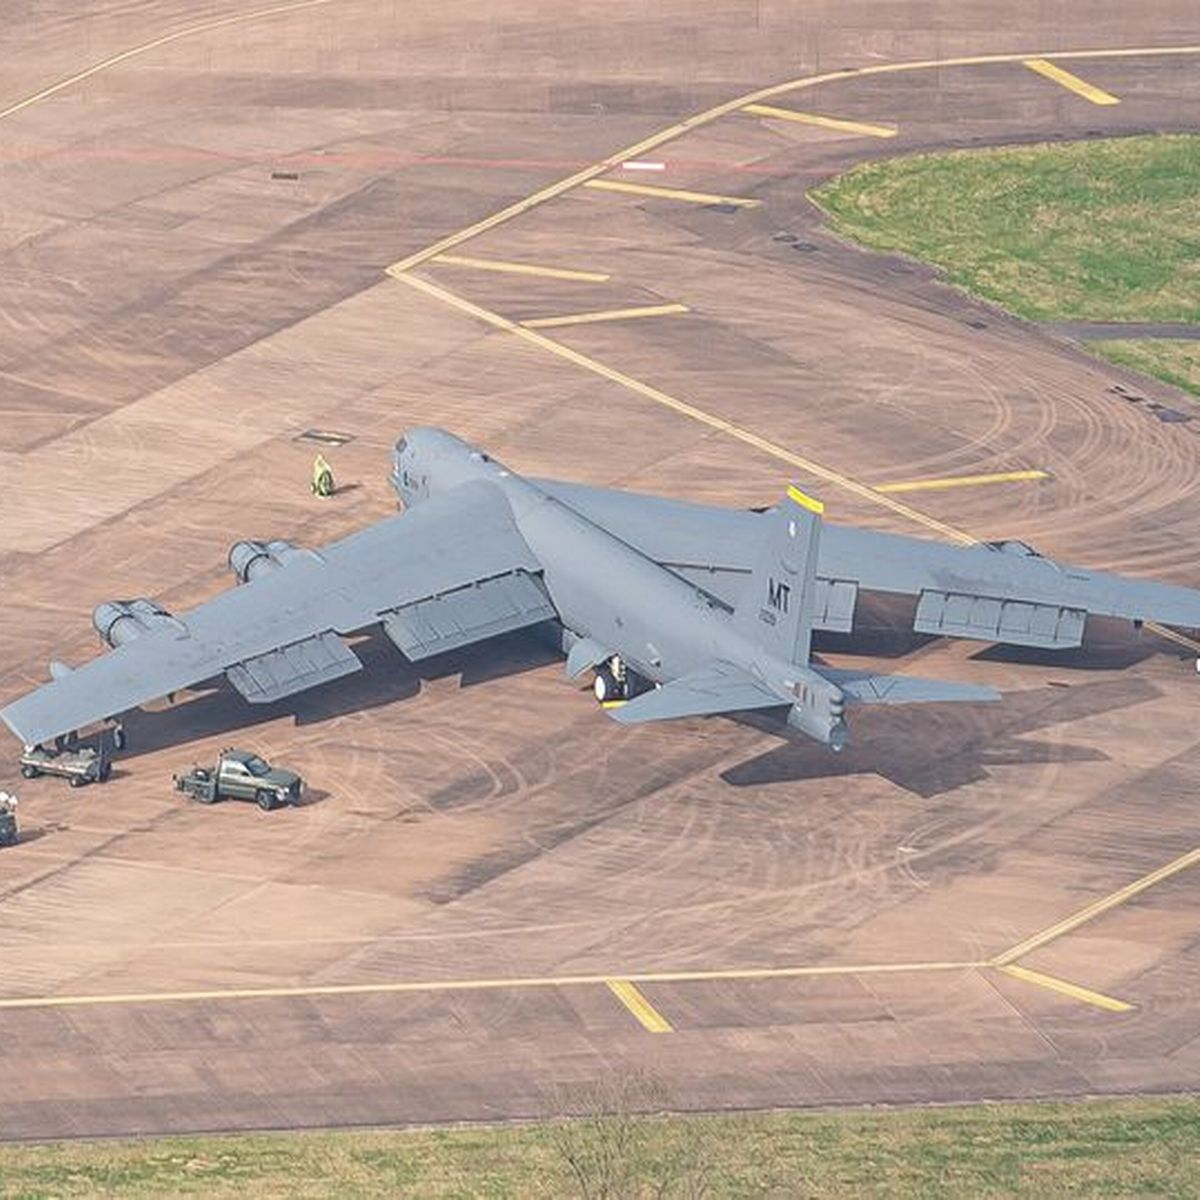Is there something that suggests the type of airplane or its specific purpose? The design and size of the aircraft suggest it's a military cargo plane, commonly used to transport troops, supplies, and equipment. This type of plane is equipped to operate in various conditions and environments, supporting military operations both domestically and internationally. 